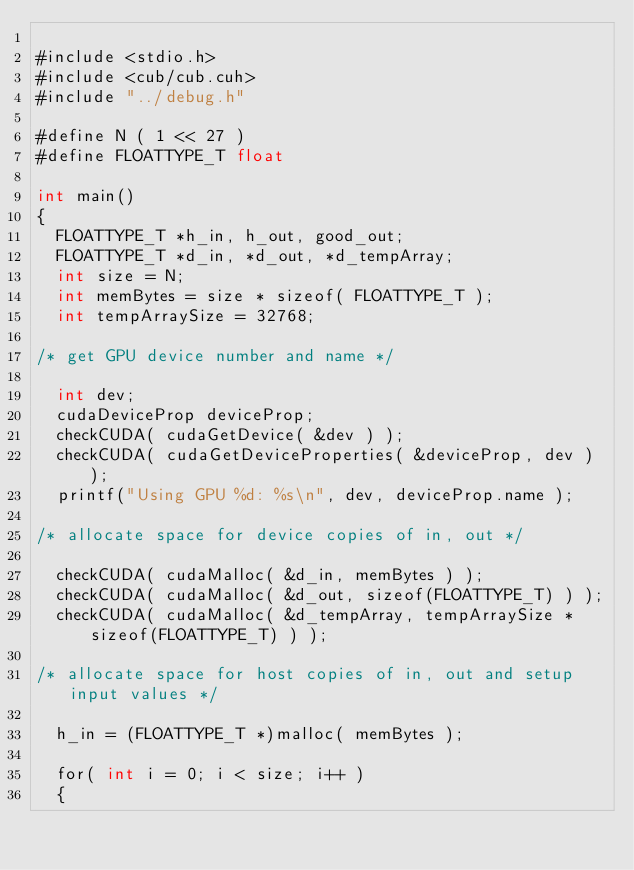Convert code to text. <code><loc_0><loc_0><loc_500><loc_500><_Cuda_>
#include <stdio.h>
#include <cub/cub.cuh>
#include "../debug.h"

#define N ( 1 << 27 )
#define FLOATTYPE_T float

int main()
{
  FLOATTYPE_T *h_in, h_out, good_out;
  FLOATTYPE_T *d_in, *d_out, *d_tempArray;
  int size = N;
  int memBytes = size * sizeof( FLOATTYPE_T );
  int tempArraySize = 32768;

/* get GPU device number and name */

  int dev;
  cudaDeviceProp deviceProp;
  checkCUDA( cudaGetDevice( &dev ) );
  checkCUDA( cudaGetDeviceProperties( &deviceProp, dev ) );
  printf("Using GPU %d: %s\n", dev, deviceProp.name );

/* allocate space for device copies of in, out */

  checkCUDA( cudaMalloc( &d_in, memBytes ) );
  checkCUDA( cudaMalloc( &d_out, sizeof(FLOATTYPE_T) ) );
  checkCUDA( cudaMalloc( &d_tempArray, tempArraySize * sizeof(FLOATTYPE_T) ) );

/* allocate space for host copies of in, out and setup input values */

  h_in = (FLOATTYPE_T *)malloc( memBytes );

  for( int i = 0; i < size; i++ )
  {</code> 